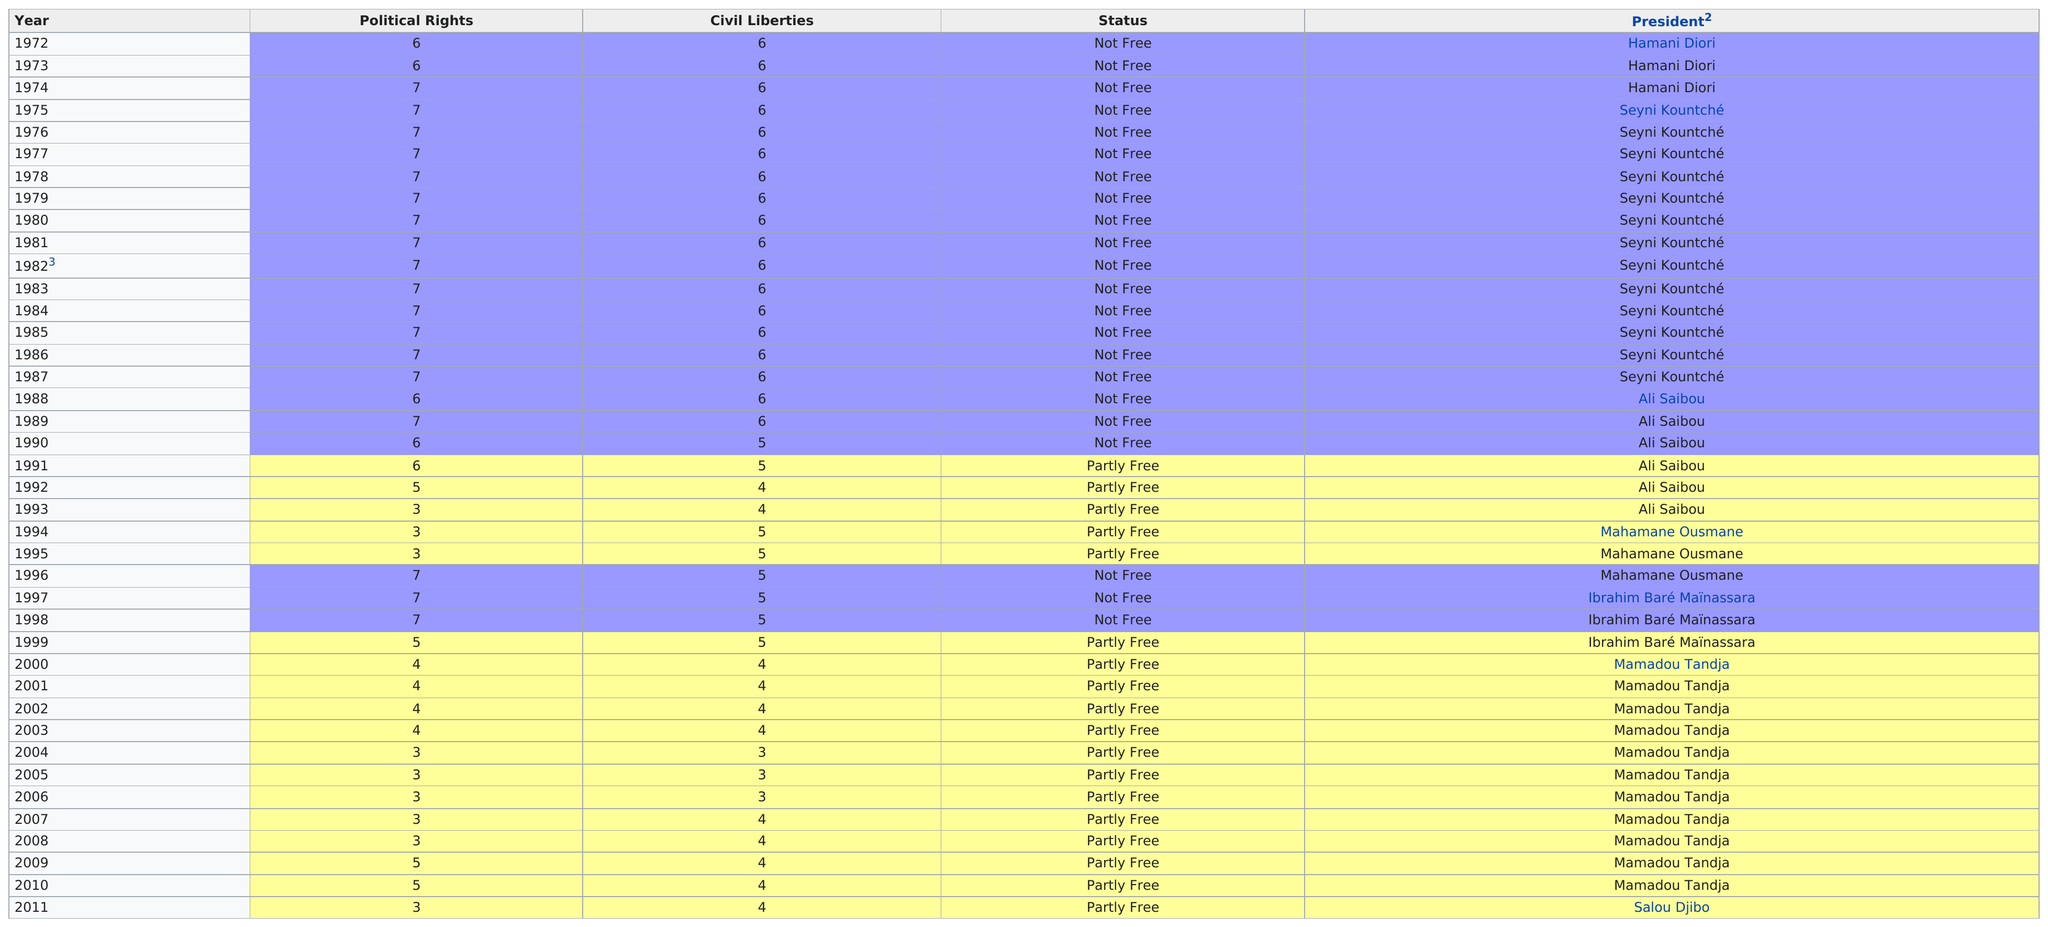Specify some key components in this picture. Ibrahim Baré Maïnassara was the president of Niger before Mamadou Tandja. The political rights were listed as seven times in total, with the number 18 being mentioned 18 times. Hamani Diori has served as President of the Republic of Niger a total of three times. I am not sure what you are asking. Could you please provide more context or clarify your question? It took 18 years for civil liberties to decrease below a score of 6 on the scale. 